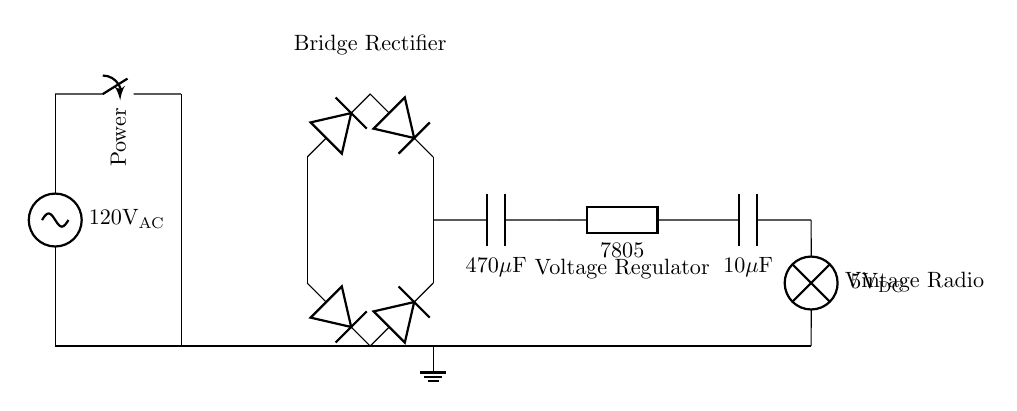What is the input voltage of the circuit? The input voltage is labeled as 120 volts AC, which is indicated by the source at the beginning of the circuit diagram.
Answer: 120 volts AC What type of component is used to convert AC to DC? The component used is a bridge rectifier, which is a configuration of diodes that converts alternating current (AC) into direct current (DC). This is indicated by the arrangement of the diodes in the circuit.
Answer: Bridge rectifier What is the purpose of the smoothing capacitor? The purpose of the smoothing capacitor is to reduce voltage fluctuations after the rectifier, effectively smoothing the output DC voltage. It is labeled as a 470 microfarad capacitor in the diagram.
Answer: To smooth voltage What voltage does the voltage regulator output? The voltage regulator outputs 5 volts DC, which is noted in the circuit as the regulated voltage from the 7805 voltage regulator.
Answer: 5 volts DC What load is powered by this circuit? The load powered by this circuit is labeled as a vintage radio, which indicates the type of appliance that this power supply is meant to operate.
Answer: Vintage radio How many capacitors are present in the circuit? There are two capacitors in the circuit: one with a value of 470 microfarads for smoothing and another with a value of 10 microfarads for output regulation. This can be counted visually from the diagram.
Answer: Two capacitors What is the role of the transformer in this circuit? The role of the transformer is to step down the voltage from the AC source to a lower level before it is rectified. It is indicated in the circuit as transforming the input voltage.
Answer: Step down voltage 